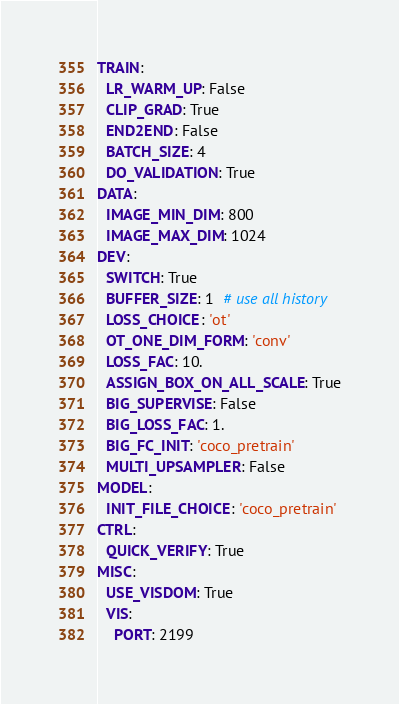<code> <loc_0><loc_0><loc_500><loc_500><_YAML_>TRAIN:
  LR_WARM_UP: False
  CLIP_GRAD: True
  END2END: False
  BATCH_SIZE: 4
  DO_VALIDATION: True
DATA:
  IMAGE_MIN_DIM: 800
  IMAGE_MAX_DIM: 1024
DEV:
  SWITCH: True
  BUFFER_SIZE: 1  # use all history
  LOSS_CHOICE: 'ot'
  OT_ONE_DIM_FORM: 'conv'
  LOSS_FAC: 10.
  ASSIGN_BOX_ON_ALL_SCALE: True
  BIG_SUPERVISE: False
  BIG_LOSS_FAC: 1.
  BIG_FC_INIT: 'coco_pretrain'
  MULTI_UPSAMPLER: False
MODEL:
  INIT_FILE_CHOICE: 'coco_pretrain'
CTRL:
  QUICK_VERIFY: True
MISC:
  USE_VISDOM: True
  VIS:
    PORT: 2199
</code> 